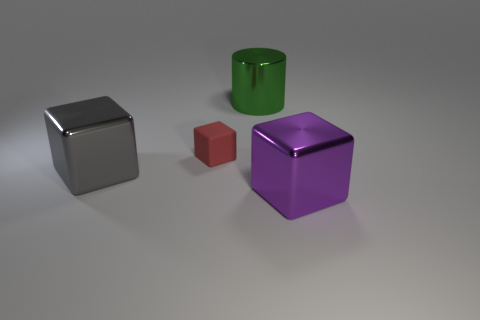Add 2 green blocks. How many objects exist? 6 Subtract all cylinders. How many objects are left? 3 Add 2 large green metallic cylinders. How many large green metallic cylinders are left? 3 Add 4 cyan cylinders. How many cyan cylinders exist? 4 Subtract 0 purple cylinders. How many objects are left? 4 Subtract all gray things. Subtract all gray blocks. How many objects are left? 2 